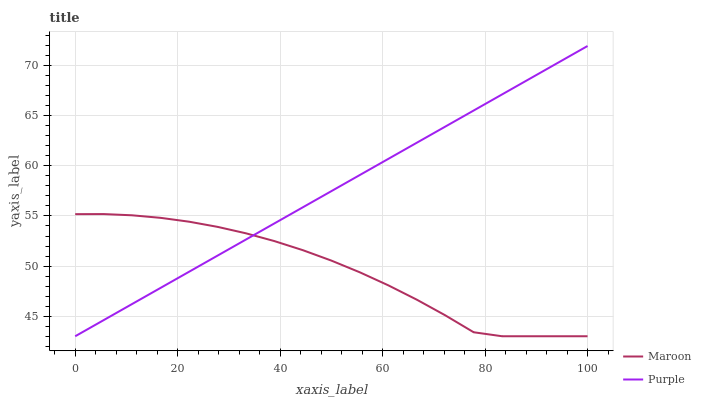Does Maroon have the minimum area under the curve?
Answer yes or no. Yes. Does Purple have the maximum area under the curve?
Answer yes or no. Yes. Does Maroon have the maximum area under the curve?
Answer yes or no. No. Is Purple the smoothest?
Answer yes or no. Yes. Is Maroon the roughest?
Answer yes or no. Yes. Is Maroon the smoothest?
Answer yes or no. No. Does Maroon have the highest value?
Answer yes or no. No. 